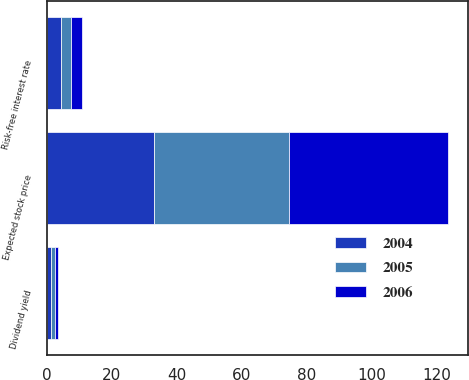Convert chart to OTSL. <chart><loc_0><loc_0><loc_500><loc_500><stacked_bar_chart><ecel><fcel>Dividend yield<fcel>Expected stock price<fcel>Risk-free interest rate<nl><fcel>2004<fcel>1.4<fcel>33<fcel>4.5<nl><fcel>2006<fcel>1<fcel>48.8<fcel>3.5<nl><fcel>2005<fcel>1.1<fcel>41.6<fcel>3<nl></chart> 